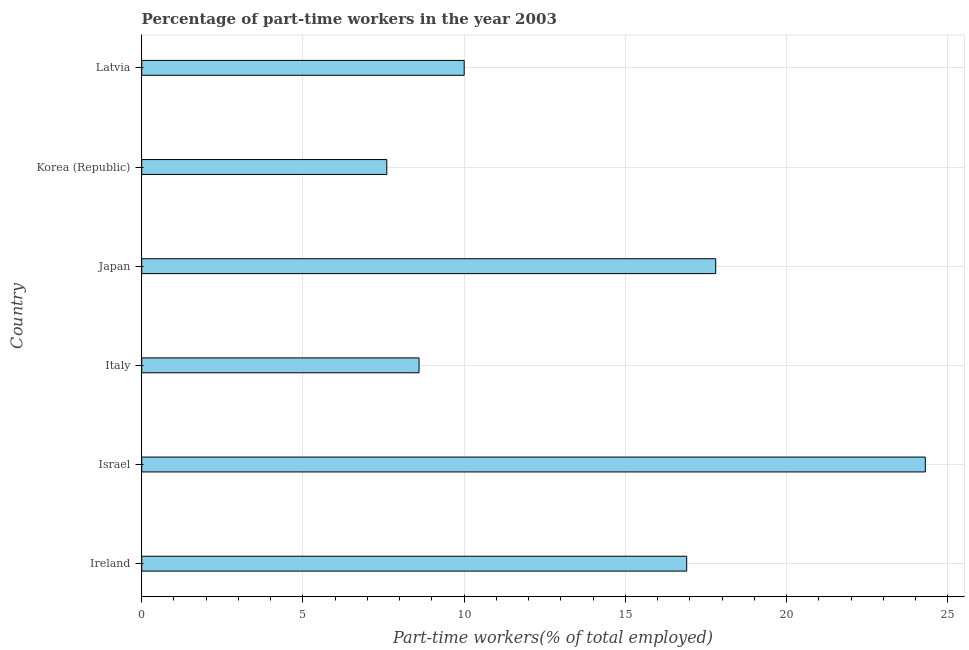Does the graph contain any zero values?
Keep it short and to the point. No. What is the title of the graph?
Make the answer very short. Percentage of part-time workers in the year 2003. What is the label or title of the X-axis?
Provide a short and direct response. Part-time workers(% of total employed). What is the label or title of the Y-axis?
Provide a short and direct response. Country. What is the percentage of part-time workers in Italy?
Provide a succinct answer. 8.6. Across all countries, what is the maximum percentage of part-time workers?
Offer a very short reply. 24.3. Across all countries, what is the minimum percentage of part-time workers?
Your response must be concise. 7.6. What is the sum of the percentage of part-time workers?
Offer a terse response. 85.2. What is the median percentage of part-time workers?
Provide a short and direct response. 13.45. In how many countries, is the percentage of part-time workers greater than 16 %?
Give a very brief answer. 3. What is the ratio of the percentage of part-time workers in Ireland to that in Italy?
Provide a succinct answer. 1.97. Is the percentage of part-time workers in Israel less than that in Korea (Republic)?
Your answer should be compact. No. What is the difference between the highest and the second highest percentage of part-time workers?
Make the answer very short. 6.5. How many bars are there?
Keep it short and to the point. 6. What is the difference between two consecutive major ticks on the X-axis?
Give a very brief answer. 5. Are the values on the major ticks of X-axis written in scientific E-notation?
Ensure brevity in your answer.  No. What is the Part-time workers(% of total employed) of Ireland?
Your response must be concise. 16.9. What is the Part-time workers(% of total employed) of Israel?
Provide a succinct answer. 24.3. What is the Part-time workers(% of total employed) in Italy?
Ensure brevity in your answer.  8.6. What is the Part-time workers(% of total employed) in Japan?
Offer a very short reply. 17.8. What is the Part-time workers(% of total employed) of Korea (Republic)?
Your answer should be compact. 7.6. What is the Part-time workers(% of total employed) of Latvia?
Ensure brevity in your answer.  10. What is the difference between the Part-time workers(% of total employed) in Ireland and Italy?
Your answer should be very brief. 8.3. What is the difference between the Part-time workers(% of total employed) in Ireland and Latvia?
Offer a very short reply. 6.9. What is the difference between the Part-time workers(% of total employed) in Israel and Japan?
Keep it short and to the point. 6.5. What is the difference between the Part-time workers(% of total employed) in Israel and Korea (Republic)?
Your answer should be compact. 16.7. What is the difference between the Part-time workers(% of total employed) in Italy and Japan?
Offer a very short reply. -9.2. What is the difference between the Part-time workers(% of total employed) in Italy and Latvia?
Your answer should be compact. -1.4. What is the difference between the Part-time workers(% of total employed) in Korea (Republic) and Latvia?
Your answer should be very brief. -2.4. What is the ratio of the Part-time workers(% of total employed) in Ireland to that in Israel?
Your answer should be very brief. 0.69. What is the ratio of the Part-time workers(% of total employed) in Ireland to that in Italy?
Offer a very short reply. 1.97. What is the ratio of the Part-time workers(% of total employed) in Ireland to that in Japan?
Provide a short and direct response. 0.95. What is the ratio of the Part-time workers(% of total employed) in Ireland to that in Korea (Republic)?
Your response must be concise. 2.22. What is the ratio of the Part-time workers(% of total employed) in Ireland to that in Latvia?
Your response must be concise. 1.69. What is the ratio of the Part-time workers(% of total employed) in Israel to that in Italy?
Ensure brevity in your answer.  2.83. What is the ratio of the Part-time workers(% of total employed) in Israel to that in Japan?
Your response must be concise. 1.36. What is the ratio of the Part-time workers(% of total employed) in Israel to that in Korea (Republic)?
Your response must be concise. 3.2. What is the ratio of the Part-time workers(% of total employed) in Israel to that in Latvia?
Offer a terse response. 2.43. What is the ratio of the Part-time workers(% of total employed) in Italy to that in Japan?
Offer a very short reply. 0.48. What is the ratio of the Part-time workers(% of total employed) in Italy to that in Korea (Republic)?
Your answer should be compact. 1.13. What is the ratio of the Part-time workers(% of total employed) in Italy to that in Latvia?
Keep it short and to the point. 0.86. What is the ratio of the Part-time workers(% of total employed) in Japan to that in Korea (Republic)?
Your answer should be compact. 2.34. What is the ratio of the Part-time workers(% of total employed) in Japan to that in Latvia?
Offer a very short reply. 1.78. What is the ratio of the Part-time workers(% of total employed) in Korea (Republic) to that in Latvia?
Give a very brief answer. 0.76. 